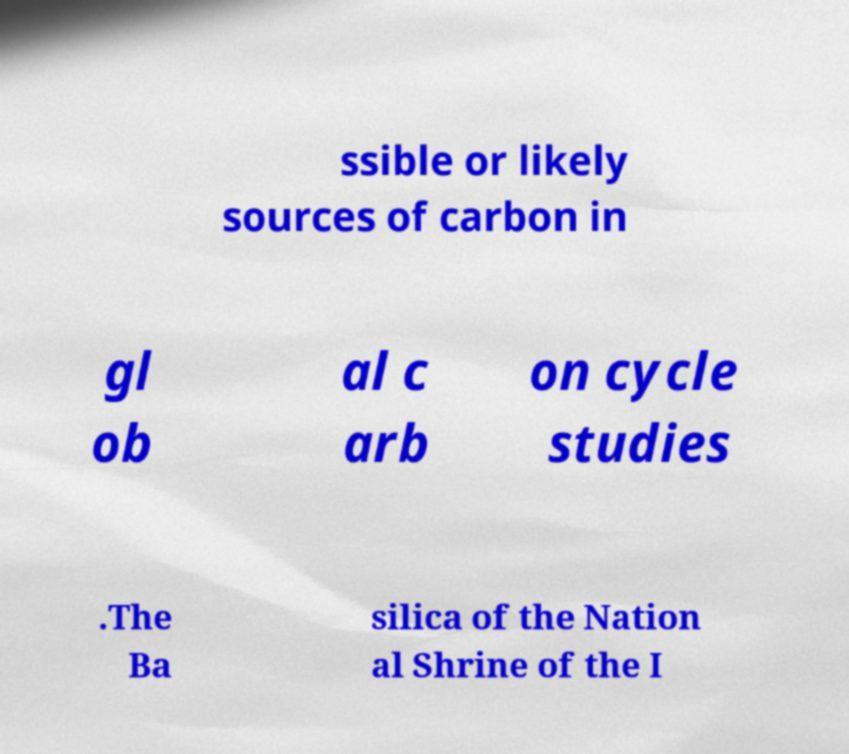Could you assist in decoding the text presented in this image and type it out clearly? ssible or likely sources of carbon in gl ob al c arb on cycle studies .The Ba silica of the Nation al Shrine of the I 